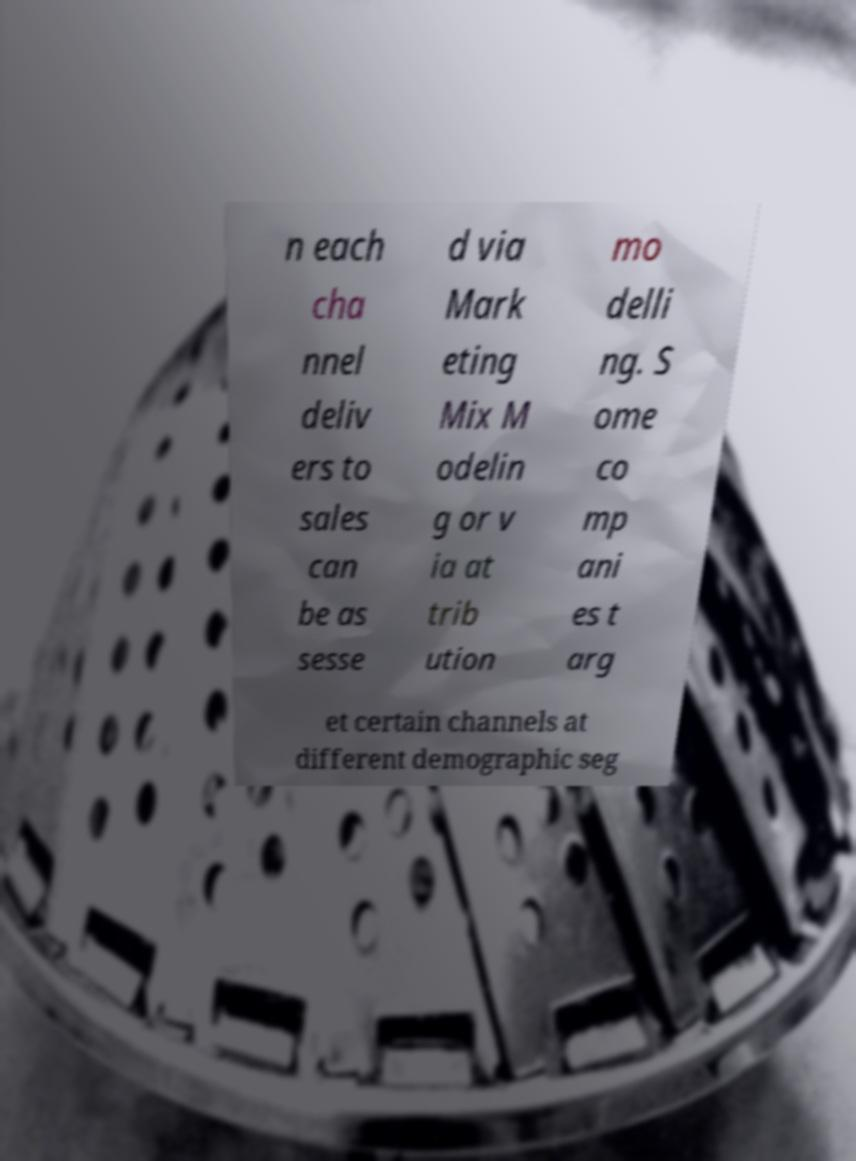Please read and relay the text visible in this image. What does it say? n each cha nnel deliv ers to sales can be as sesse d via Mark eting Mix M odelin g or v ia at trib ution mo delli ng. S ome co mp ani es t arg et certain channels at different demographic seg 